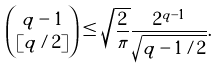<formula> <loc_0><loc_0><loc_500><loc_500>\binom { q - 1 } { [ q / 2 ] } \leq \sqrt { \frac { 2 } { \pi } } \frac { 2 ^ { q - 1 } } { \sqrt { q - 1 / 2 } } .</formula> 